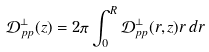<formula> <loc_0><loc_0><loc_500><loc_500>\mathcal { D } ^ { \perp } _ { p p } ( z ) = 2 \pi \int _ { 0 } ^ { R } \mathcal { D } ^ { \perp } _ { p p } ( r , z ) r \, d r</formula> 